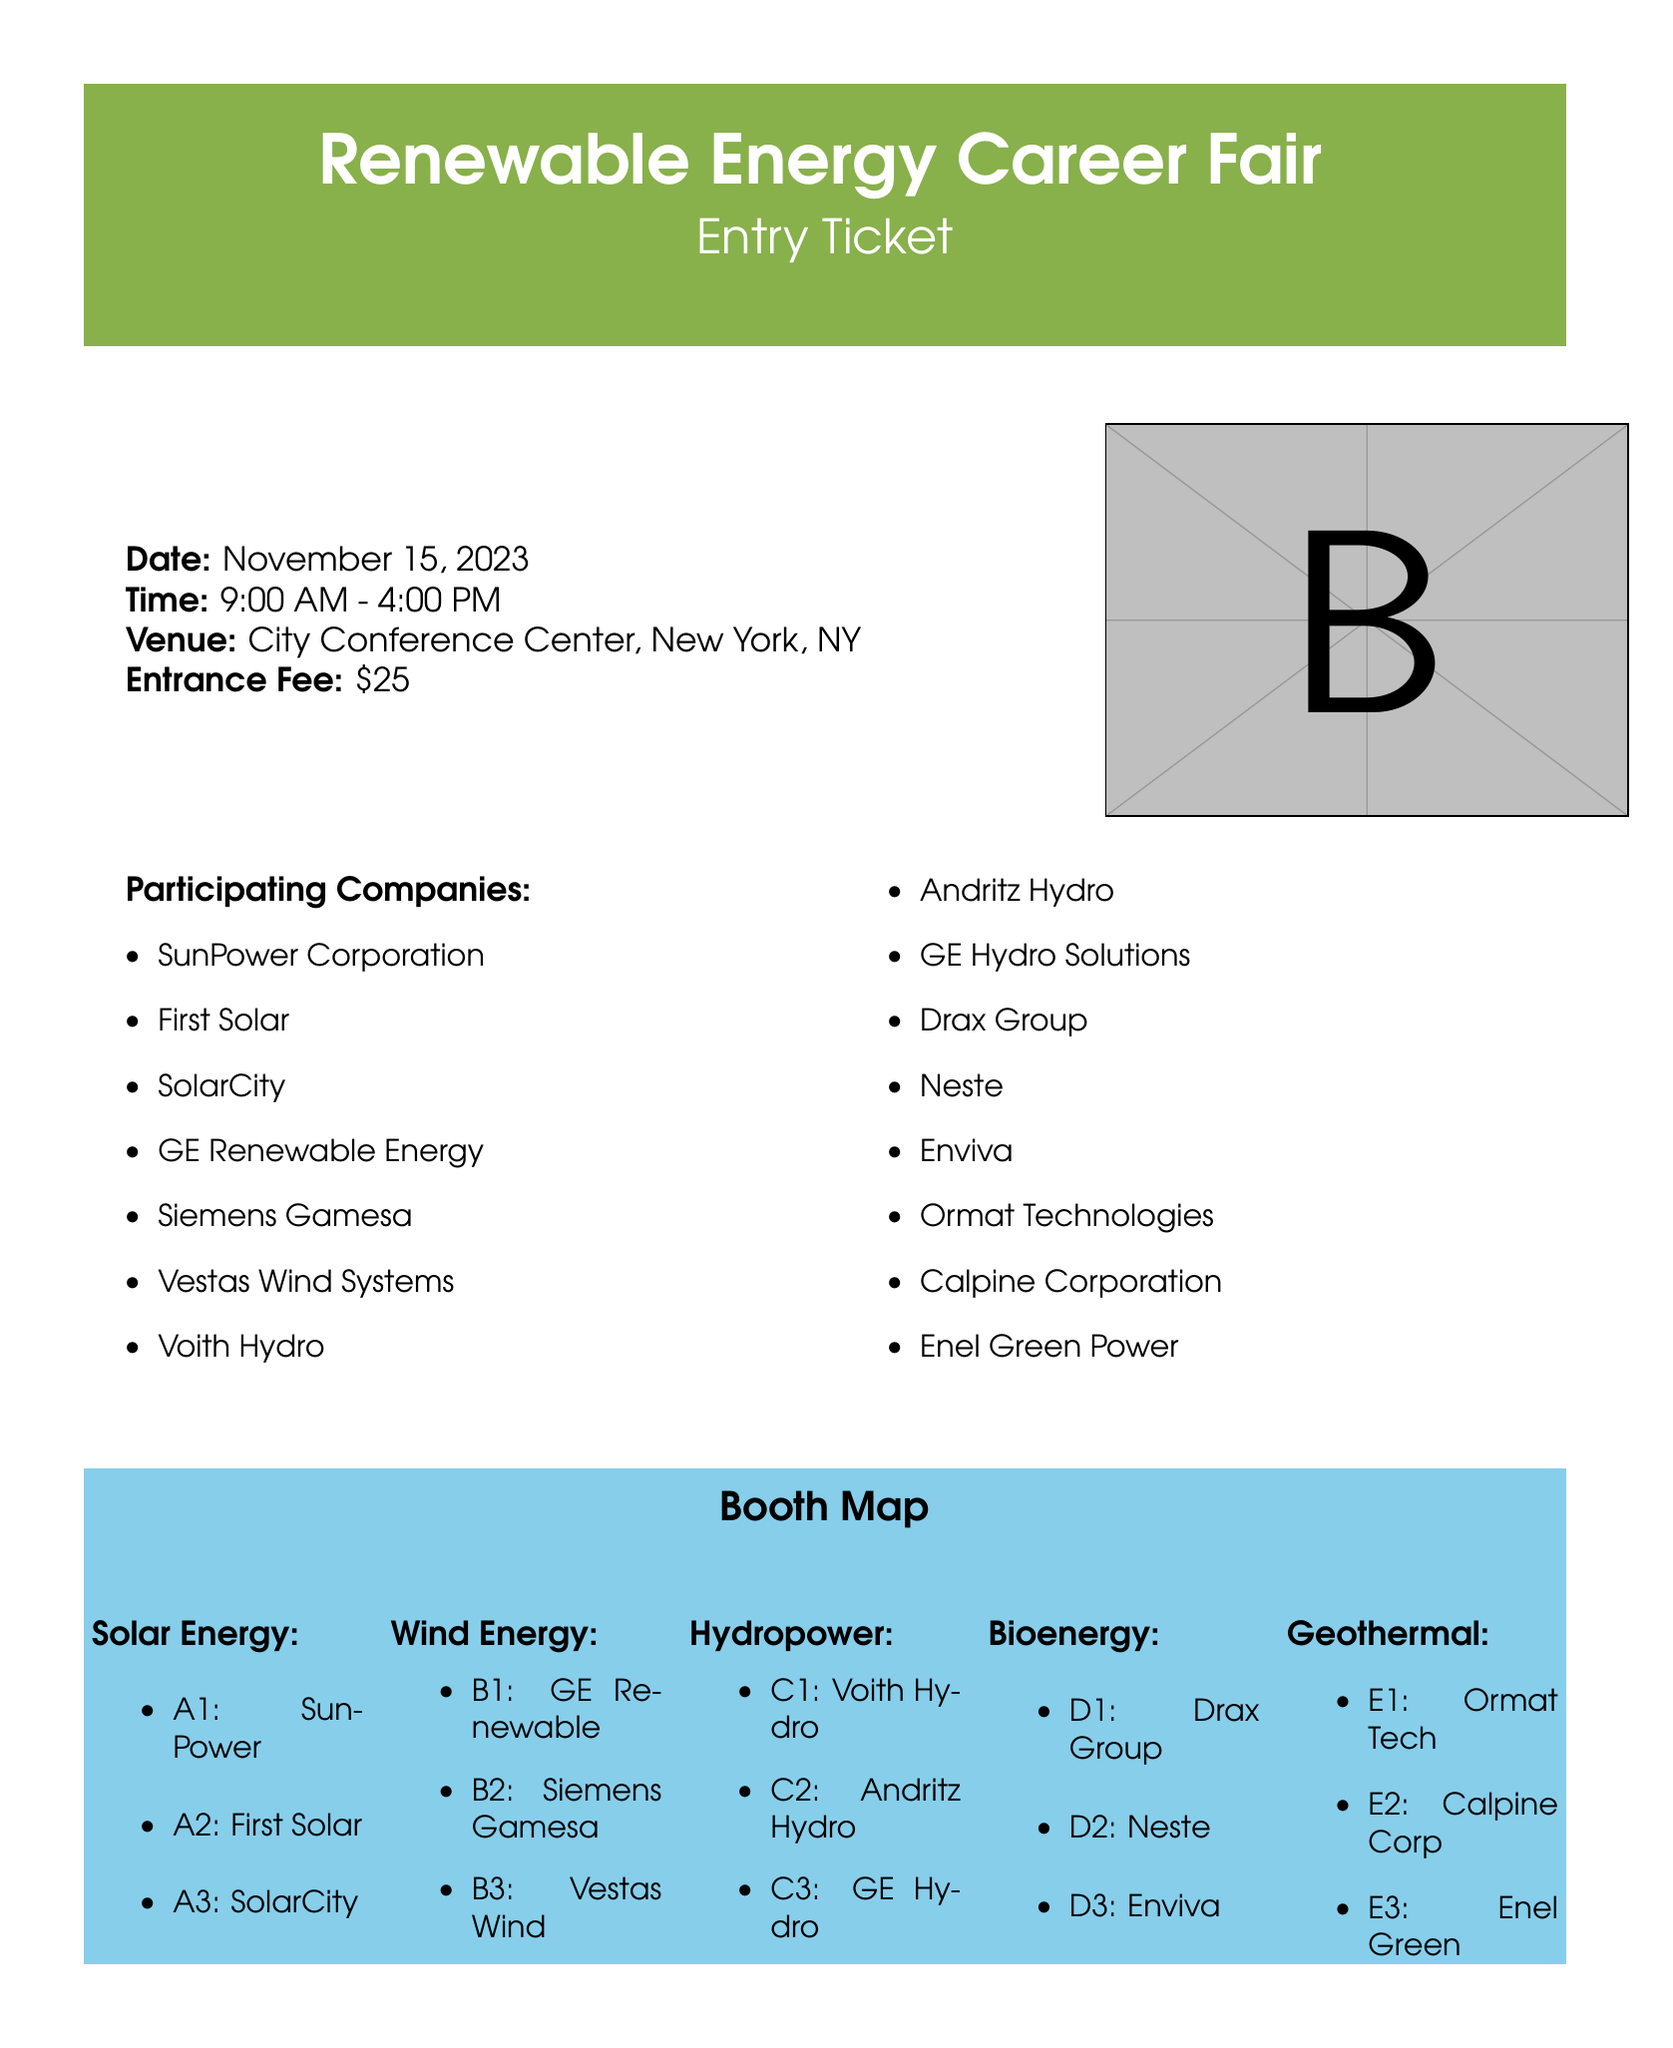What is the date of the career fair? The date of the career fair is explicitly mentioned in the document.
Answer: November 15, 2023 What is the entrance fee? The entrance fee is clearly stated in the document.
Answer: $25 How many companies are participating? The document lists several companies, which can be counted for the total.
Answer: 15 What time does the career fair start? The starting time of the event is provided in the document's details.
Answer: 9:00 AM Which company is at booth A1? The booth assignments for companies are detailed in the booth map section.
Answer: SunPower What type of energy does Siemens Gamesa focus on? The document categorizes participating companies by energy types.
Answer: Wind Energy What is the registration deadline? The document includes a specific date for registration deadline.
Answer: November 1, 2023 Where is the venue located? The venue location is listed in the document's details.
Answer: City Conference Center, New York, NY How many booths are allocated for solar energy companies? The booth map specifies how many solar energy booths there are.
Answer: 3 